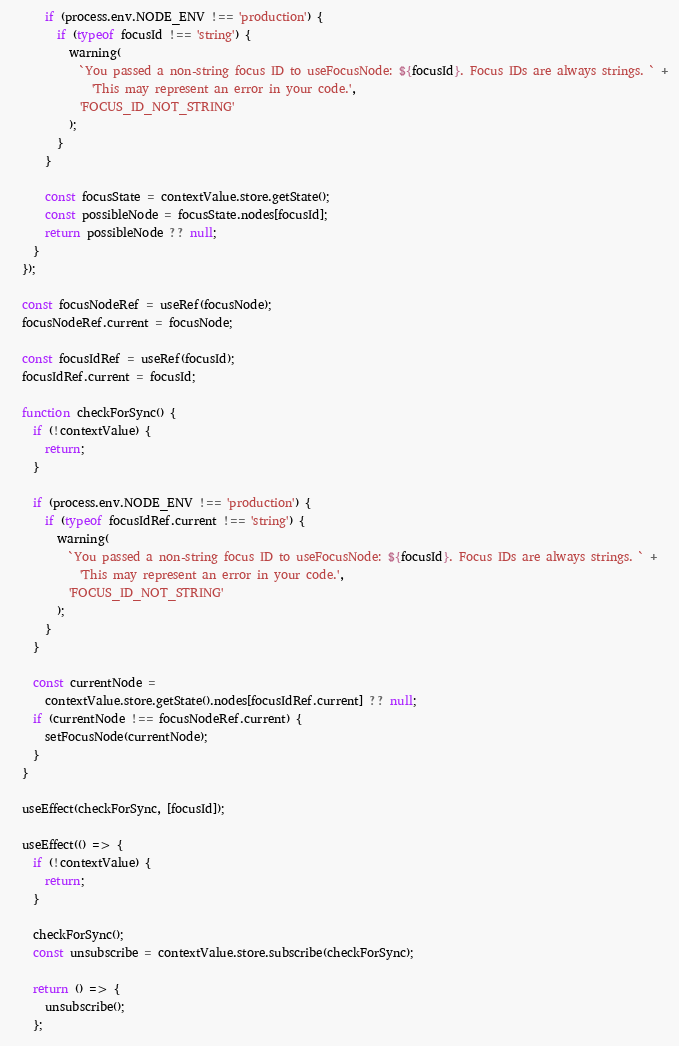Convert code to text. <code><loc_0><loc_0><loc_500><loc_500><_TypeScript_>      if (process.env.NODE_ENV !== 'production') {
        if (typeof focusId !== 'string') {
          warning(
            `You passed a non-string focus ID to useFocusNode: ${focusId}. Focus IDs are always strings. ` +
              'This may represent an error in your code.',
            'FOCUS_ID_NOT_STRING'
          );
        }
      }

      const focusState = contextValue.store.getState();
      const possibleNode = focusState.nodes[focusId];
      return possibleNode ?? null;
    }
  });

  const focusNodeRef = useRef(focusNode);
  focusNodeRef.current = focusNode;

  const focusIdRef = useRef(focusId);
  focusIdRef.current = focusId;

  function checkForSync() {
    if (!contextValue) {
      return;
    }

    if (process.env.NODE_ENV !== 'production') {
      if (typeof focusIdRef.current !== 'string') {
        warning(
          `You passed a non-string focus ID to useFocusNode: ${focusId}. Focus IDs are always strings. ` +
            'This may represent an error in your code.',
          'FOCUS_ID_NOT_STRING'
        );
      }
    }

    const currentNode =
      contextValue.store.getState().nodes[focusIdRef.current] ?? null;
    if (currentNode !== focusNodeRef.current) {
      setFocusNode(currentNode);
    }
  }

  useEffect(checkForSync, [focusId]);

  useEffect(() => {
    if (!contextValue) {
      return;
    }

    checkForSync();
    const unsubscribe = contextValue.store.subscribe(checkForSync);

    return () => {
      unsubscribe();
    };</code> 